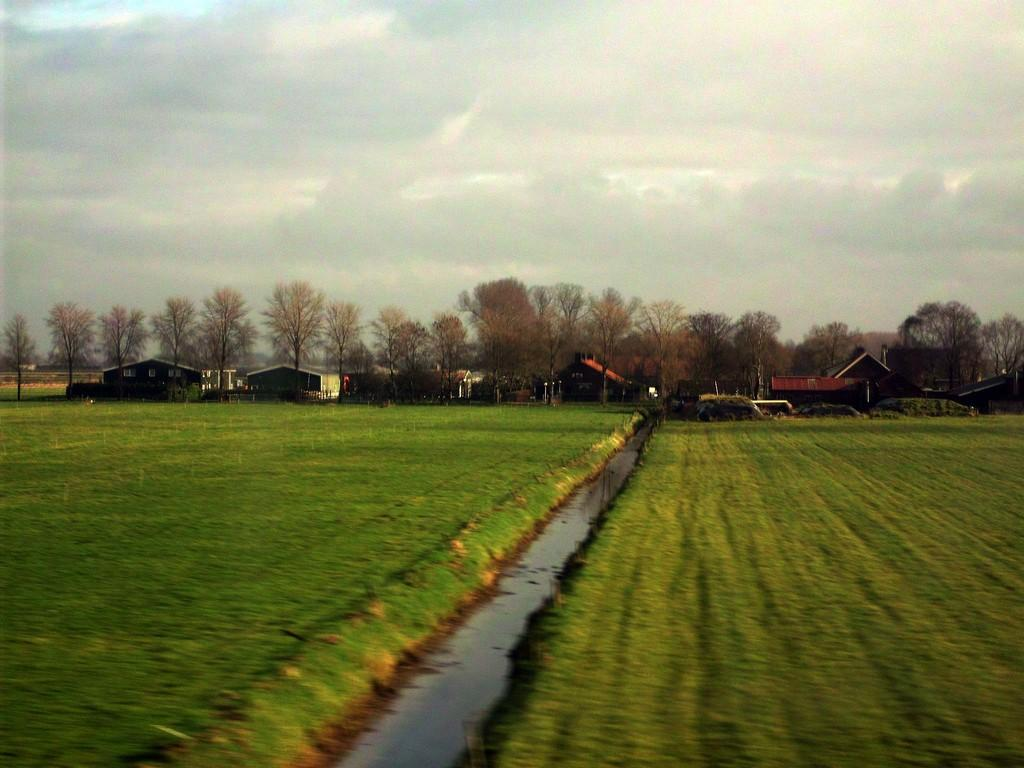What type of landscape is depicted in the image? The image features fields. What natural element can be seen in the image? Water is visible in the image. What type of structures are present in the image? There are houses in the image. What type of vegetation is present in the image? Trees are present in the image. What is the condition of the sky in the image? The sky is clear in the image. Can you see an umbrella being used by someone in the image? There is no umbrella present in the image. What color is the tongue of the tree in the image? Trees do not have tongues, so this question is not applicable to the image. 